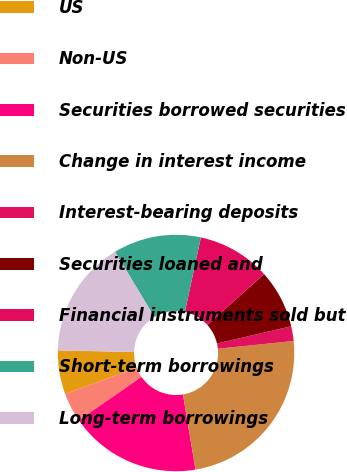Convert chart to OTSL. <chart><loc_0><loc_0><loc_500><loc_500><pie_chart><fcel>Deposits with banks<fcel>US<fcel>Non-US<fcel>Securities borrowed securities<fcel>Change in interest income<fcel>Interest-bearing deposits<fcel>Securities loaned and<fcel>Financial instruments sold but<fcel>Short-term borrowings<fcel>Long-term borrowings<nl><fcel>0.01%<fcel>6.0%<fcel>4.0%<fcel>17.99%<fcel>23.99%<fcel>2.01%<fcel>8.0%<fcel>10.0%<fcel>12.0%<fcel>16.0%<nl></chart> 